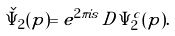<formula> <loc_0><loc_0><loc_500><loc_500>\check { \Psi } _ { 2 } ( p ) = e ^ { 2 \pi i s } \, D \, \Psi ^ { c } _ { 2 } ( p ) .</formula> 